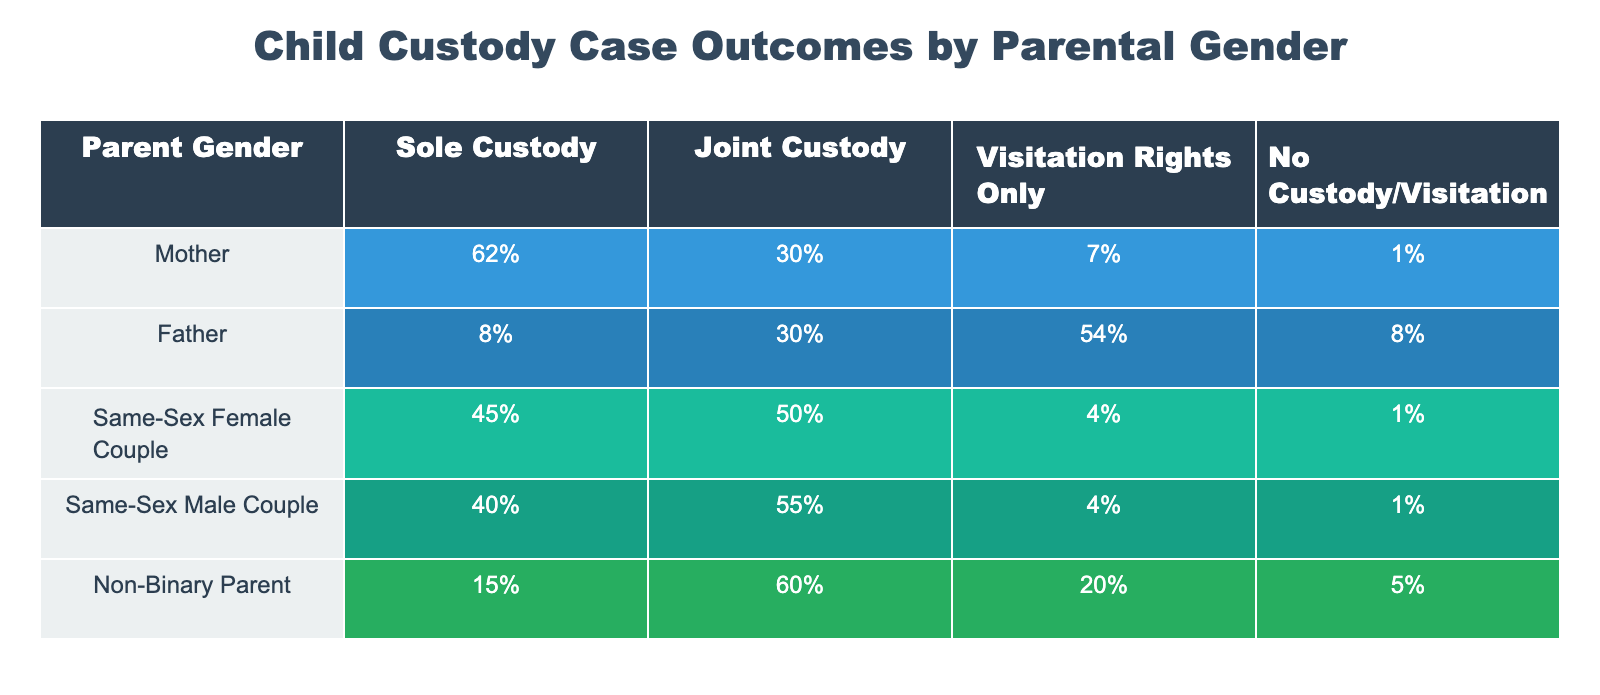What percentage of fathers have sole custody? From the table, the percentage of fathers who have sole custody is given directly as 8%.
Answer: 8% What is the percentage of single mothers who have joint custody? The table shows that 30% of mothers have joint custody, so the answer is directly available from the data provided.
Answer: 30% Which group has the highest percentage of visitation rights only? By examining the visitation rights column, the highest percentage is observed for fathers at 54%.
Answer: 54% What percentage of same-sex female couples have sole custody compared to non-binary parents? The table indicates that 45% of same-sex female couples have sole custody, while 15% of non-binary parents have sole custody. The difference is 45% - 15% = 30%.
Answer: 30% Do more fathers have visitation rights only than non-binary parents? The table lists 54% for fathers and 20% for non-binary parents for visitation rights. Since 54% is greater than 20%, the answer is yes.
Answer: Yes What is the total percentage of joint custody awarded to same-sex male couples and non-binary parents combined? For same-sex male couples, the percentage for joint custody is 55% and for non-binary parents, it is 60%. Therefore, adding them gives 55% + 60% = 115%.
Answer: 115% What is the overall percentage of parents on the table who do not have custody or visitation rights? Sum the percentages of those with "No Custody/Visitation" in each row: 1% (mothers) + 8% (fathers) + 1% (same-sex female couples) + 1% (same-sex male couples) + 5% (non-binary parents), resulting in 16%.
Answer: 16% Is it true that all groups have at least some percentage of sole custody awarded to them? Checking the table, mothers, same-sex female couples, same-sex male couples, and non-binary parents all have percentages for sole custody, but fathers do not. Hence, the statement is false.
Answer: False What is the percentage difference in joint custody between same-sex female couples and same-sex male couples? From the table, same-sex female couples have 50% joint custody, while same-sex male couples have 55%. The difference is 55% - 50% = 5%.
Answer: 5% 